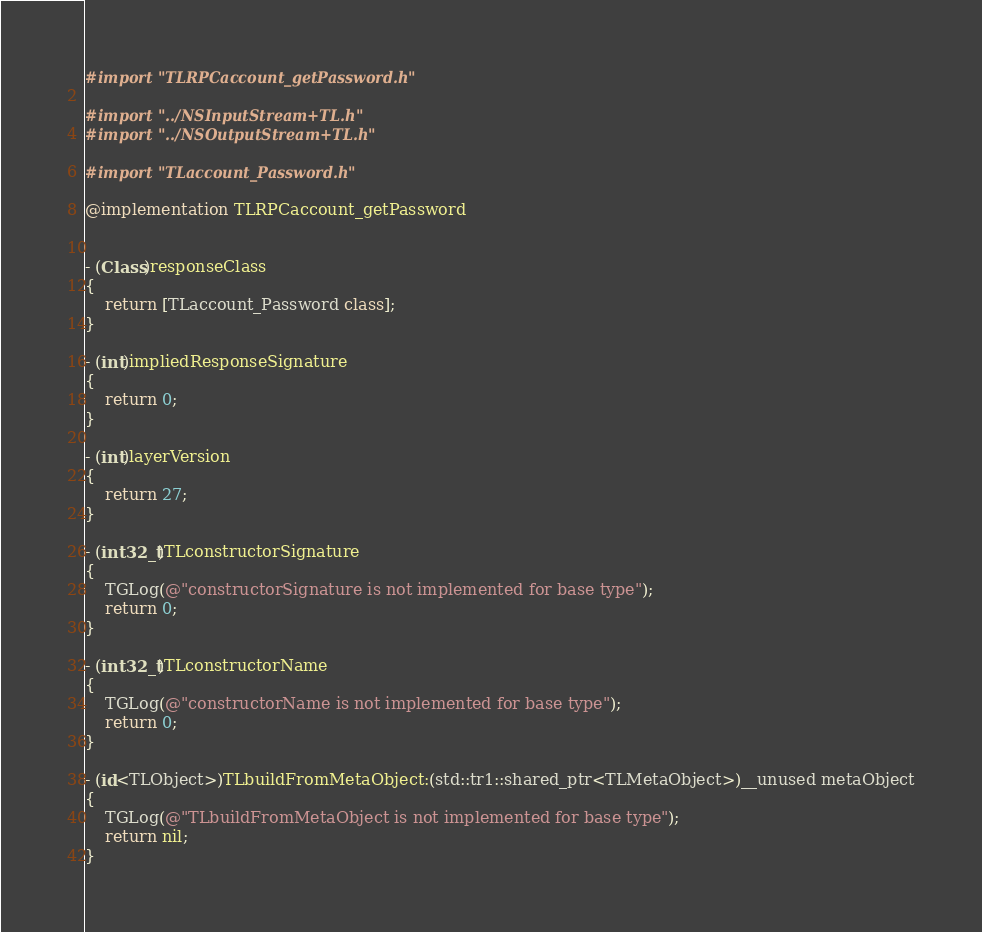Convert code to text. <code><loc_0><loc_0><loc_500><loc_500><_ObjectiveC_>#import "TLRPCaccount_getPassword.h"

#import "../NSInputStream+TL.h"
#import "../NSOutputStream+TL.h"

#import "TLaccount_Password.h"

@implementation TLRPCaccount_getPassword


- (Class)responseClass
{
    return [TLaccount_Password class];
}

- (int)impliedResponseSignature
{
    return 0;
}

- (int)layerVersion
{
    return 27;
}

- (int32_t)TLconstructorSignature
{
    TGLog(@"constructorSignature is not implemented for base type");
    return 0;
}

- (int32_t)TLconstructorName
{
    TGLog(@"constructorName is not implemented for base type");
    return 0;
}

- (id<TLObject>)TLbuildFromMetaObject:(std::tr1::shared_ptr<TLMetaObject>)__unused metaObject
{
    TGLog(@"TLbuildFromMetaObject is not implemented for base type");
    return nil;
}
</code> 